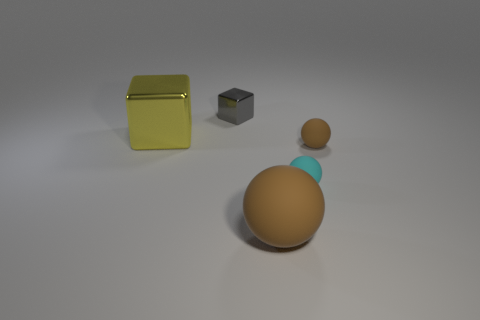The big metallic cube has what color?
Your answer should be very brief. Yellow. Are there fewer brown rubber spheres that are to the right of the big rubber ball than small brown balls?
Your answer should be very brief. No. Are there any big spheres?
Keep it short and to the point. Yes. Are there fewer small purple cubes than gray shiny cubes?
Ensure brevity in your answer.  Yes. What number of objects have the same material as the big cube?
Keep it short and to the point. 1. The large sphere that is the same material as the tiny cyan thing is what color?
Offer a very short reply. Brown. What is the shape of the cyan thing?
Make the answer very short. Sphere. How many small matte spheres have the same color as the large sphere?
Give a very brief answer. 1. What is the shape of the object that is the same size as the yellow block?
Your answer should be compact. Sphere. Is there a brown thing of the same size as the yellow metallic block?
Ensure brevity in your answer.  Yes. 